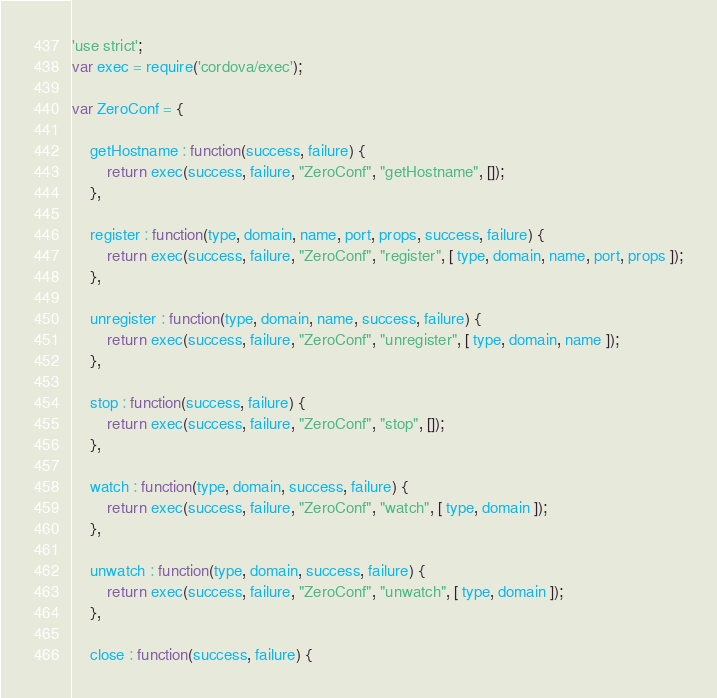<code> <loc_0><loc_0><loc_500><loc_500><_JavaScript_>'use strict';
var exec = require('cordova/exec');

var ZeroConf = {

    getHostname : function(success, failure) {
        return exec(success, failure, "ZeroConf", "getHostname", []);
    },

    register : function(type, domain, name, port, props, success, failure) {
        return exec(success, failure, "ZeroConf", "register", [ type, domain, name, port, props ]);
    },

    unregister : function(type, domain, name, success, failure) {
        return exec(success, failure, "ZeroConf", "unregister", [ type, domain, name ]);
    },

    stop : function(success, failure) {
        return exec(success, failure, "ZeroConf", "stop", []);
    },

    watch : function(type, domain, success, failure) {
        return exec(success, failure, "ZeroConf", "watch", [ type, domain ]);
    },

    unwatch : function(type, domain, success, failure) {
        return exec(success, failure, "ZeroConf", "unwatch", [ type, domain ]);
    },

    close : function(success, failure) {</code> 